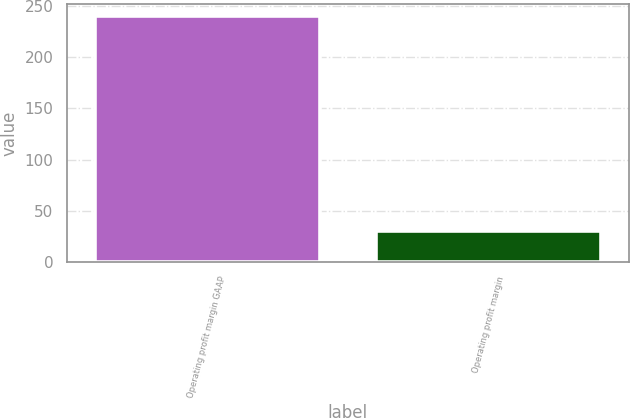Convert chart to OTSL. <chart><loc_0><loc_0><loc_500><loc_500><bar_chart><fcel>Operating profit margin GAAP<fcel>Operating profit margin<nl><fcel>240<fcel>30<nl></chart> 